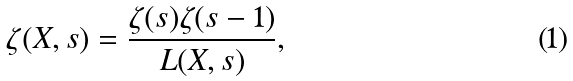<formula> <loc_0><loc_0><loc_500><loc_500>\zeta ( X , s ) = \frac { \zeta ( s ) \zeta ( s - 1 ) } { L ( X , s ) } ,</formula> 